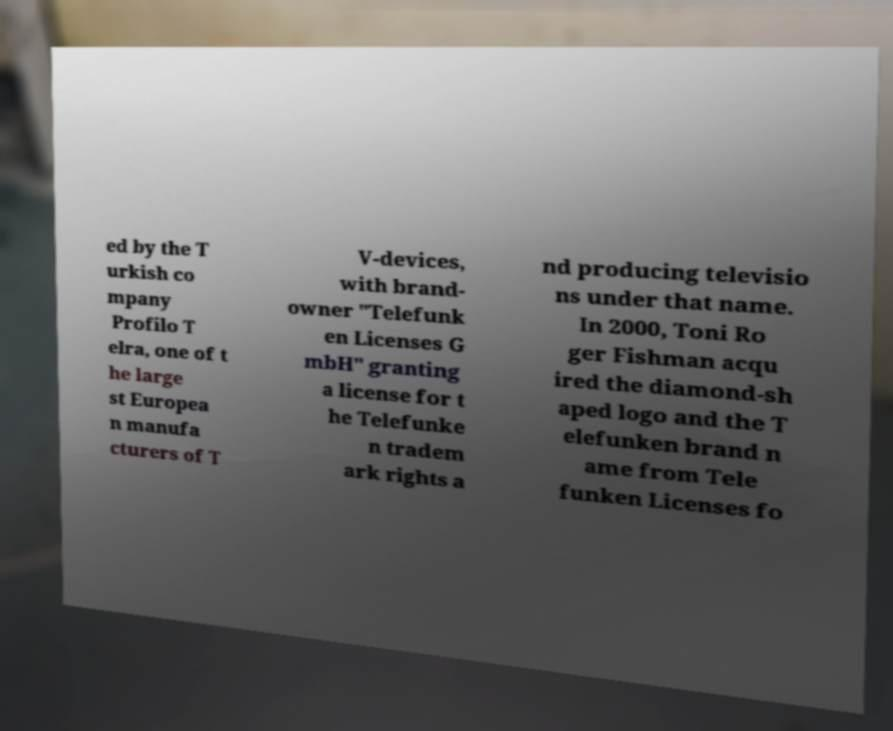For documentation purposes, I need the text within this image transcribed. Could you provide that? ed by the T urkish co mpany Profilo T elra, one of t he large st Europea n manufa cturers of T V-devices, with brand- owner "Telefunk en Licenses G mbH" granting a license for t he Telefunke n tradem ark rights a nd producing televisio ns under that name. In 2000, Toni Ro ger Fishman acqu ired the diamond-sh aped logo and the T elefunken brand n ame from Tele funken Licenses fo 